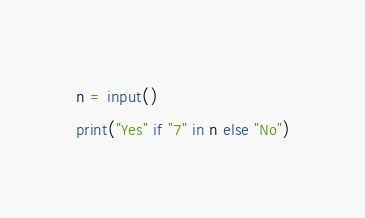<code> <loc_0><loc_0><loc_500><loc_500><_Python_>n = input()
print("Yes" if "7" in n else "No")</code> 